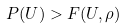<formula> <loc_0><loc_0><loc_500><loc_500>P ( U ) > F ( U , \rho )</formula> 